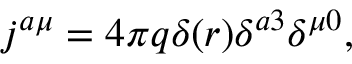<formula> <loc_0><loc_0><loc_500><loc_500>j ^ { a \mu } = 4 \pi q \delta ( r ) \delta ^ { a 3 } \delta ^ { \mu 0 } ,</formula> 